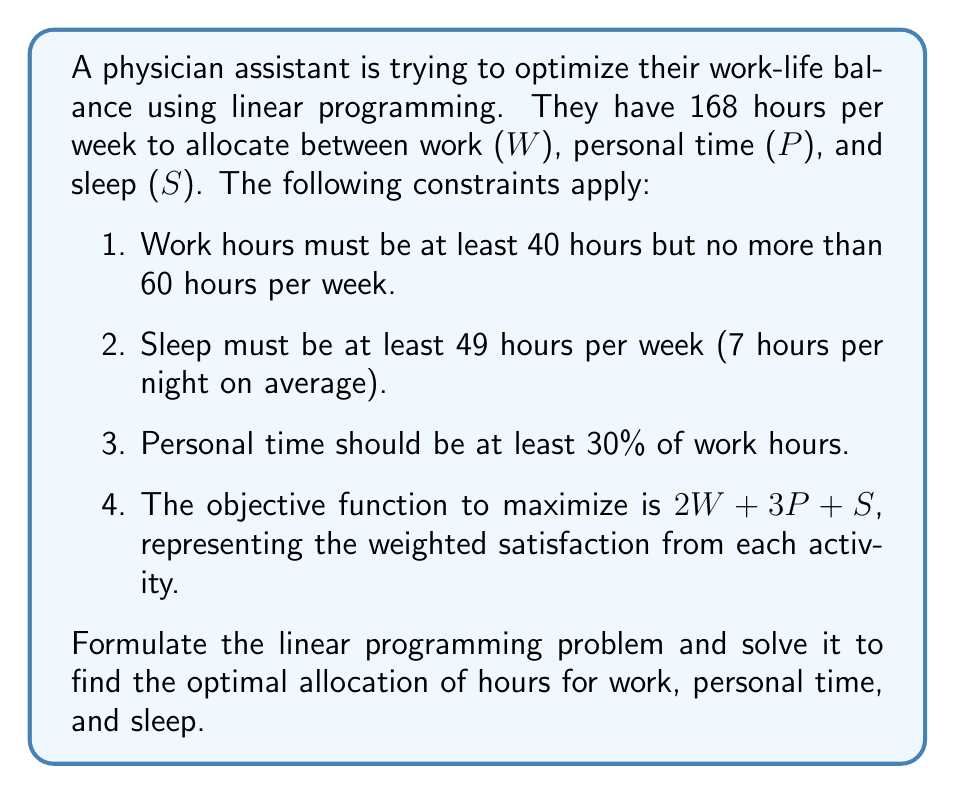Can you answer this question? Let's approach this step-by-step:

1) First, we'll define our variables:
   W = work hours
   P = personal time hours
   S = sleep hours

2) Now, let's formulate the constraints:
   a) Total hours: $W + P + S = 168$
   b) Work hours: $40 \leq W \leq 60$
   c) Sleep hours: $S \geq 49$
   d) Personal time: $P \geq 0.3W$

3) Our objective function to maximize is:
   $\text{Maximize } 2W + 3P + S$

4) Now we have our complete linear programming problem:

   $\text{Maximize } 2W + 3P + S$
   Subject to:
   $W + P + S = 168$
   $40 \leq W \leq 60$
   $S \geq 49$
   $P \geq 0.3W$
   $W, P, S \geq 0$

5) To solve this, we can use the simplex method or a linear programming solver. However, we can also reason through it:

   a) Since the coefficient of P is highest in the objective function, we want to maximize P.
   b) P is constrained by W (P ≥ 0.3W), so we want to minimize W to its lower bound of 40 hours.
   c) Setting W = 40, we get P ≥ 12.
   d) S has a lower bound of 49.

6) Plugging these into the total hours constraint:
   $40 + P + 49 = 168$
   $P = 79$

7) This satisfies all constraints and maximizes the objective function.

Therefore, the optimal solution is:
W = 40 hours
P = 79 hours
S = 49 hours

We can verify that this satisfies all constraints and maximizes the objective function.
Answer: The optimal work-life balance allocation is:
Work (W) = 40 hours
Personal time (P) = 79 hours
Sleep (S) = 49 hours

This results in a maximum satisfaction value of:
$2(40) + 3(79) + 49 = 366$ 